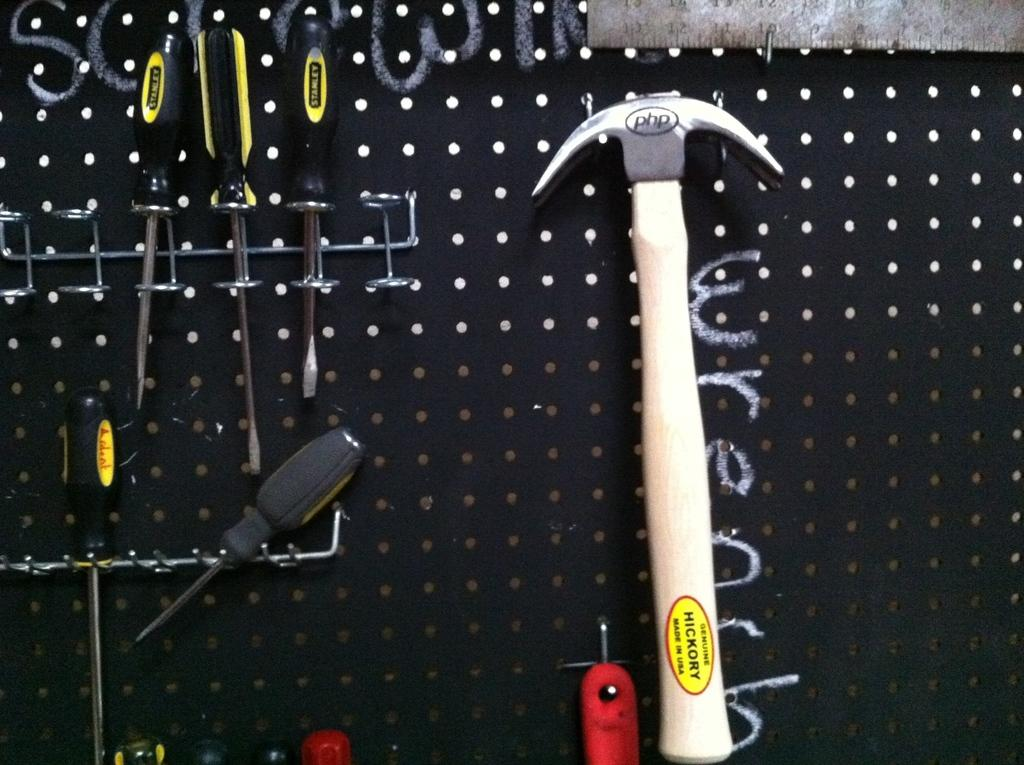What is the color of the surface in the image? The surface in the image is black. What tool can be seen on the black surface? A hammer is present on the black surface. What other tools are visible on the black surface? There are screwdrivers on the black surface. Are there any tools hanging on the black surface? Yes, there are other tools hanging on the black surface. What type of creature is responsible for the shock in the image? There is no creature or shock present in the image; it features a black surface with tools on it. 